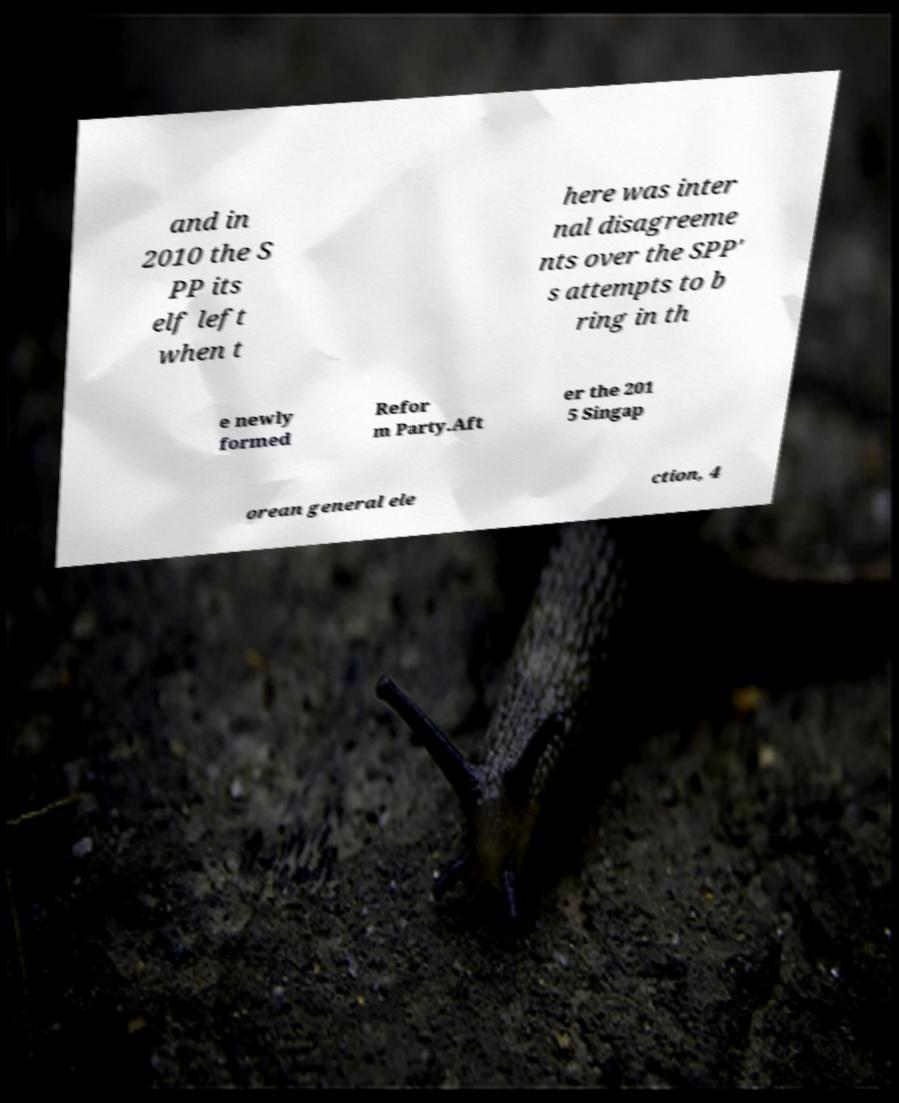Can you read and provide the text displayed in the image?This photo seems to have some interesting text. Can you extract and type it out for me? and in 2010 the S PP its elf left when t here was inter nal disagreeme nts over the SPP' s attempts to b ring in th e newly formed Refor m Party.Aft er the 201 5 Singap orean general ele ction, 4 